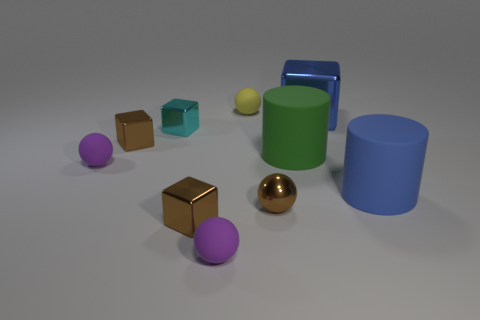Subtract all blue blocks. How many blocks are left? 3 Subtract all yellow balls. How many balls are left? 3 Subtract 1 cyan cubes. How many objects are left? 9 Subtract all cylinders. How many objects are left? 8 Subtract 1 cubes. How many cubes are left? 3 Subtract all brown cubes. Subtract all yellow spheres. How many cubes are left? 2 Subtract all red spheres. How many yellow blocks are left? 0 Subtract all cyan matte spheres. Subtract all tiny matte balls. How many objects are left? 7 Add 5 large objects. How many large objects are left? 8 Add 8 big brown metal balls. How many big brown metal balls exist? 8 